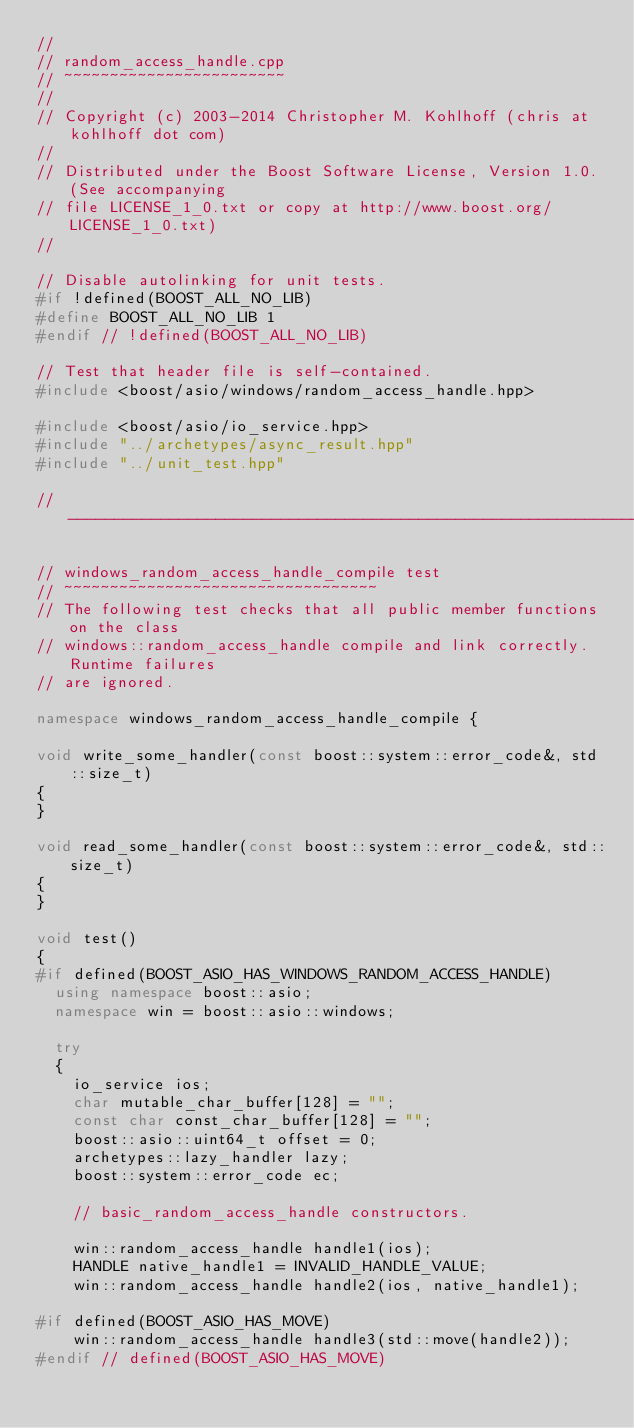Convert code to text. <code><loc_0><loc_0><loc_500><loc_500><_C++_>//
// random_access_handle.cpp
// ~~~~~~~~~~~~~~~~~~~~~~~~
//
// Copyright (c) 2003-2014 Christopher M. Kohlhoff (chris at kohlhoff dot com)
//
// Distributed under the Boost Software License, Version 1.0. (See accompanying
// file LICENSE_1_0.txt or copy at http://www.boost.org/LICENSE_1_0.txt)
//

// Disable autolinking for unit tests.
#if !defined(BOOST_ALL_NO_LIB)
#define BOOST_ALL_NO_LIB 1
#endif // !defined(BOOST_ALL_NO_LIB)

// Test that header file is self-contained.
#include <boost/asio/windows/random_access_handle.hpp>

#include <boost/asio/io_service.hpp>
#include "../archetypes/async_result.hpp"
#include "../unit_test.hpp"

//------------------------------------------------------------------------------

// windows_random_access_handle_compile test
// ~~~~~~~~~~~~~~~~~~~~~~~~~~~~~~~~~~
// The following test checks that all public member functions on the class
// windows::random_access_handle compile and link correctly. Runtime failures
// are ignored.

namespace windows_random_access_handle_compile {

void write_some_handler(const boost::system::error_code&, std::size_t)
{
}

void read_some_handler(const boost::system::error_code&, std::size_t)
{
}

void test()
{
#if defined(BOOST_ASIO_HAS_WINDOWS_RANDOM_ACCESS_HANDLE)
  using namespace boost::asio;
  namespace win = boost::asio::windows;

  try
  {
    io_service ios;
    char mutable_char_buffer[128] = "";
    const char const_char_buffer[128] = "";
    boost::asio::uint64_t offset = 0;
    archetypes::lazy_handler lazy;
    boost::system::error_code ec;

    // basic_random_access_handle constructors.

    win::random_access_handle handle1(ios);
    HANDLE native_handle1 = INVALID_HANDLE_VALUE;
    win::random_access_handle handle2(ios, native_handle1);

#if defined(BOOST_ASIO_HAS_MOVE)
    win::random_access_handle handle3(std::move(handle2));
#endif // defined(BOOST_ASIO_HAS_MOVE)
</code> 